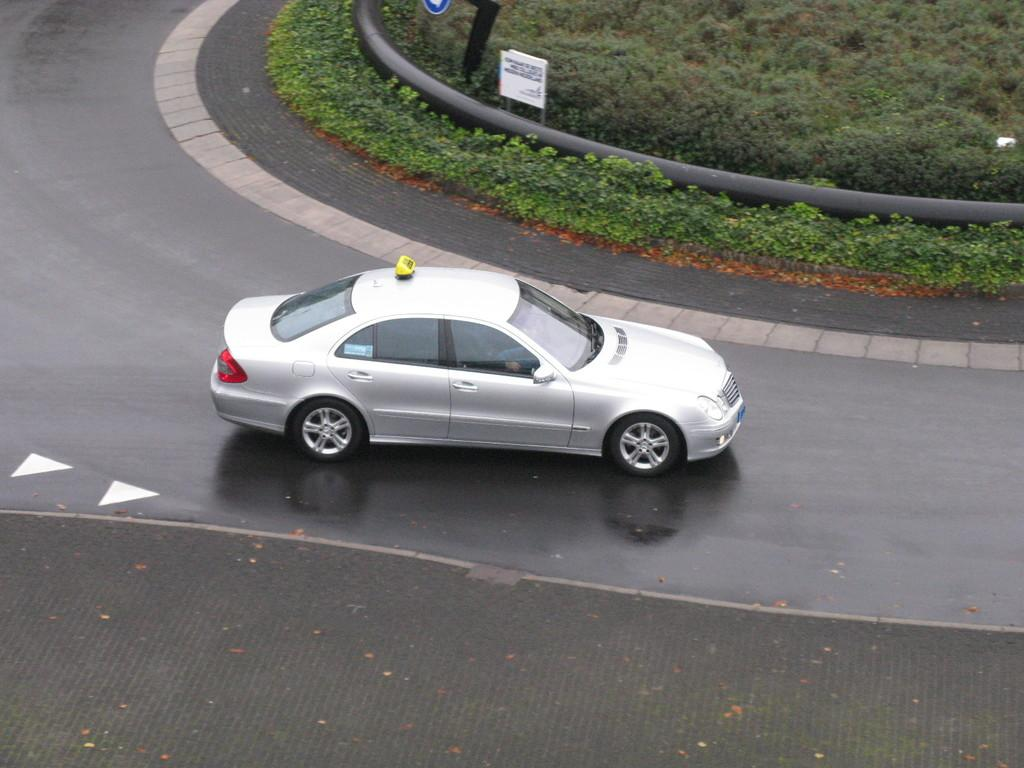What is the main subject of the image? There is a vehicle in the image. What can be seen beneath the vehicle? The ground is visible in the image. What type of vegetation is present in the image? There is grass and plants in the image. What other objects can be seen in the image? There are boards, a pipe, and a metal object in the image. What type of curtain is covering the vehicle in the image? There is no curtain present in the image; the vehicle is not covered. What color is the copper pipe in the image? There is no copper pipe present in the image; the pipe mentioned in the facts is not specified to be made of copper. 